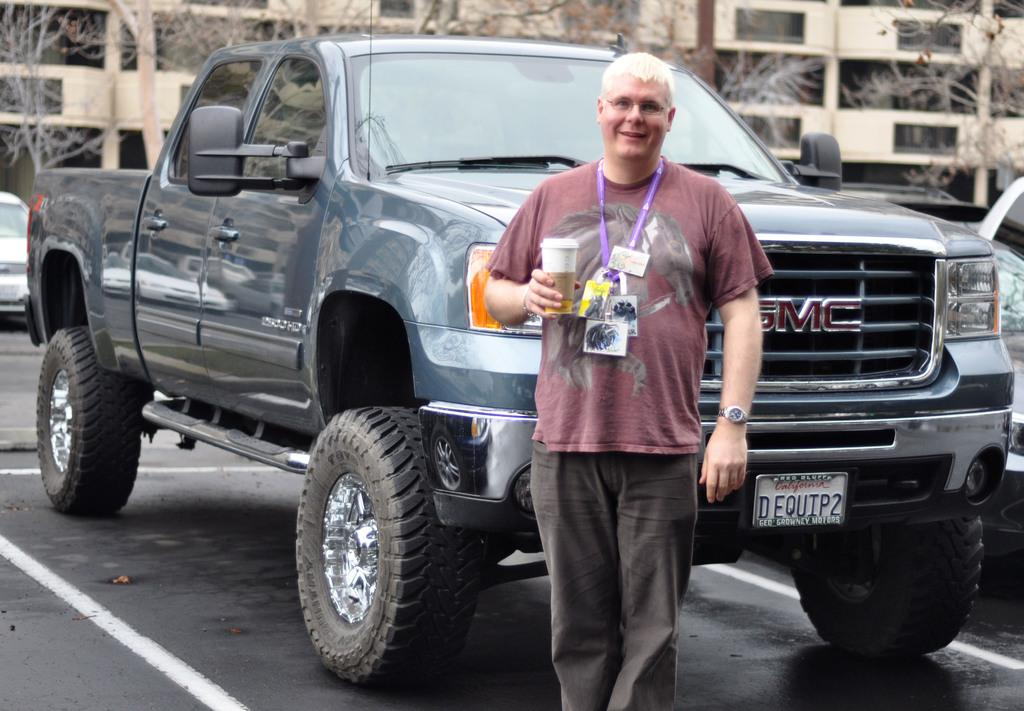What is the man in the image holding? The man is holding a paper cup. Where is the man standing in the image? The man is standing on the road. What can be seen behind the man in the image? There is a vehicle behind the man. What is visible in the background of the image? There are trees and buildings in the background of the image. What type of popcorn is the man eating in the image? There is no popcorn present in the image; the man is holding a paper cup. 